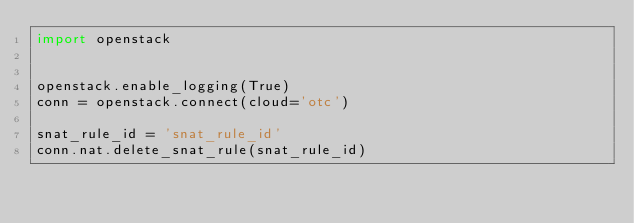Convert code to text. <code><loc_0><loc_0><loc_500><loc_500><_Python_>import openstack


openstack.enable_logging(True)
conn = openstack.connect(cloud='otc')

snat_rule_id = 'snat_rule_id'
conn.nat.delete_snat_rule(snat_rule_id)
</code> 